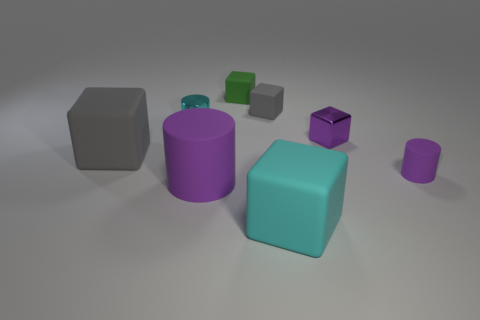Do the metal object that is to the right of the tiny green matte cube and the large matte cylinder have the same color?
Make the answer very short. Yes. There is a block that is the same color as the large rubber cylinder; what is its material?
Offer a very short reply. Metal. The block that is the same color as the metal cylinder is what size?
Provide a succinct answer. Large. Is the color of the large matte block behind the big cyan rubber thing the same as the small matte block that is right of the green matte object?
Offer a very short reply. Yes. Is there a tiny rubber thing of the same color as the big cylinder?
Provide a succinct answer. Yes. There is a gray object in front of the small metallic cylinder; what is its shape?
Your answer should be very brief. Cube. Does the cyan rubber thing have the same shape as the gray object that is right of the cyan cylinder?
Offer a very short reply. Yes. There is a rubber cube that is both on the right side of the small green block and in front of the small gray matte block; what is its size?
Your answer should be compact. Large. What is the color of the matte thing that is both left of the small purple metal cube and right of the small gray object?
Give a very brief answer. Cyan. Are there fewer cyan cubes on the left side of the tiny cyan cylinder than big matte objects that are behind the large rubber cylinder?
Give a very brief answer. Yes. 